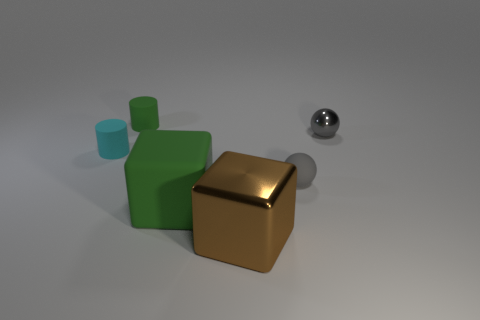Add 2 small matte cylinders. How many objects exist? 8 Subtract all blocks. How many objects are left? 4 Add 6 small things. How many small things are left? 10 Add 4 big cyan objects. How many big cyan objects exist? 4 Subtract 0 brown cylinders. How many objects are left? 6 Subtract all tiny spheres. Subtract all brown metallic cubes. How many objects are left? 3 